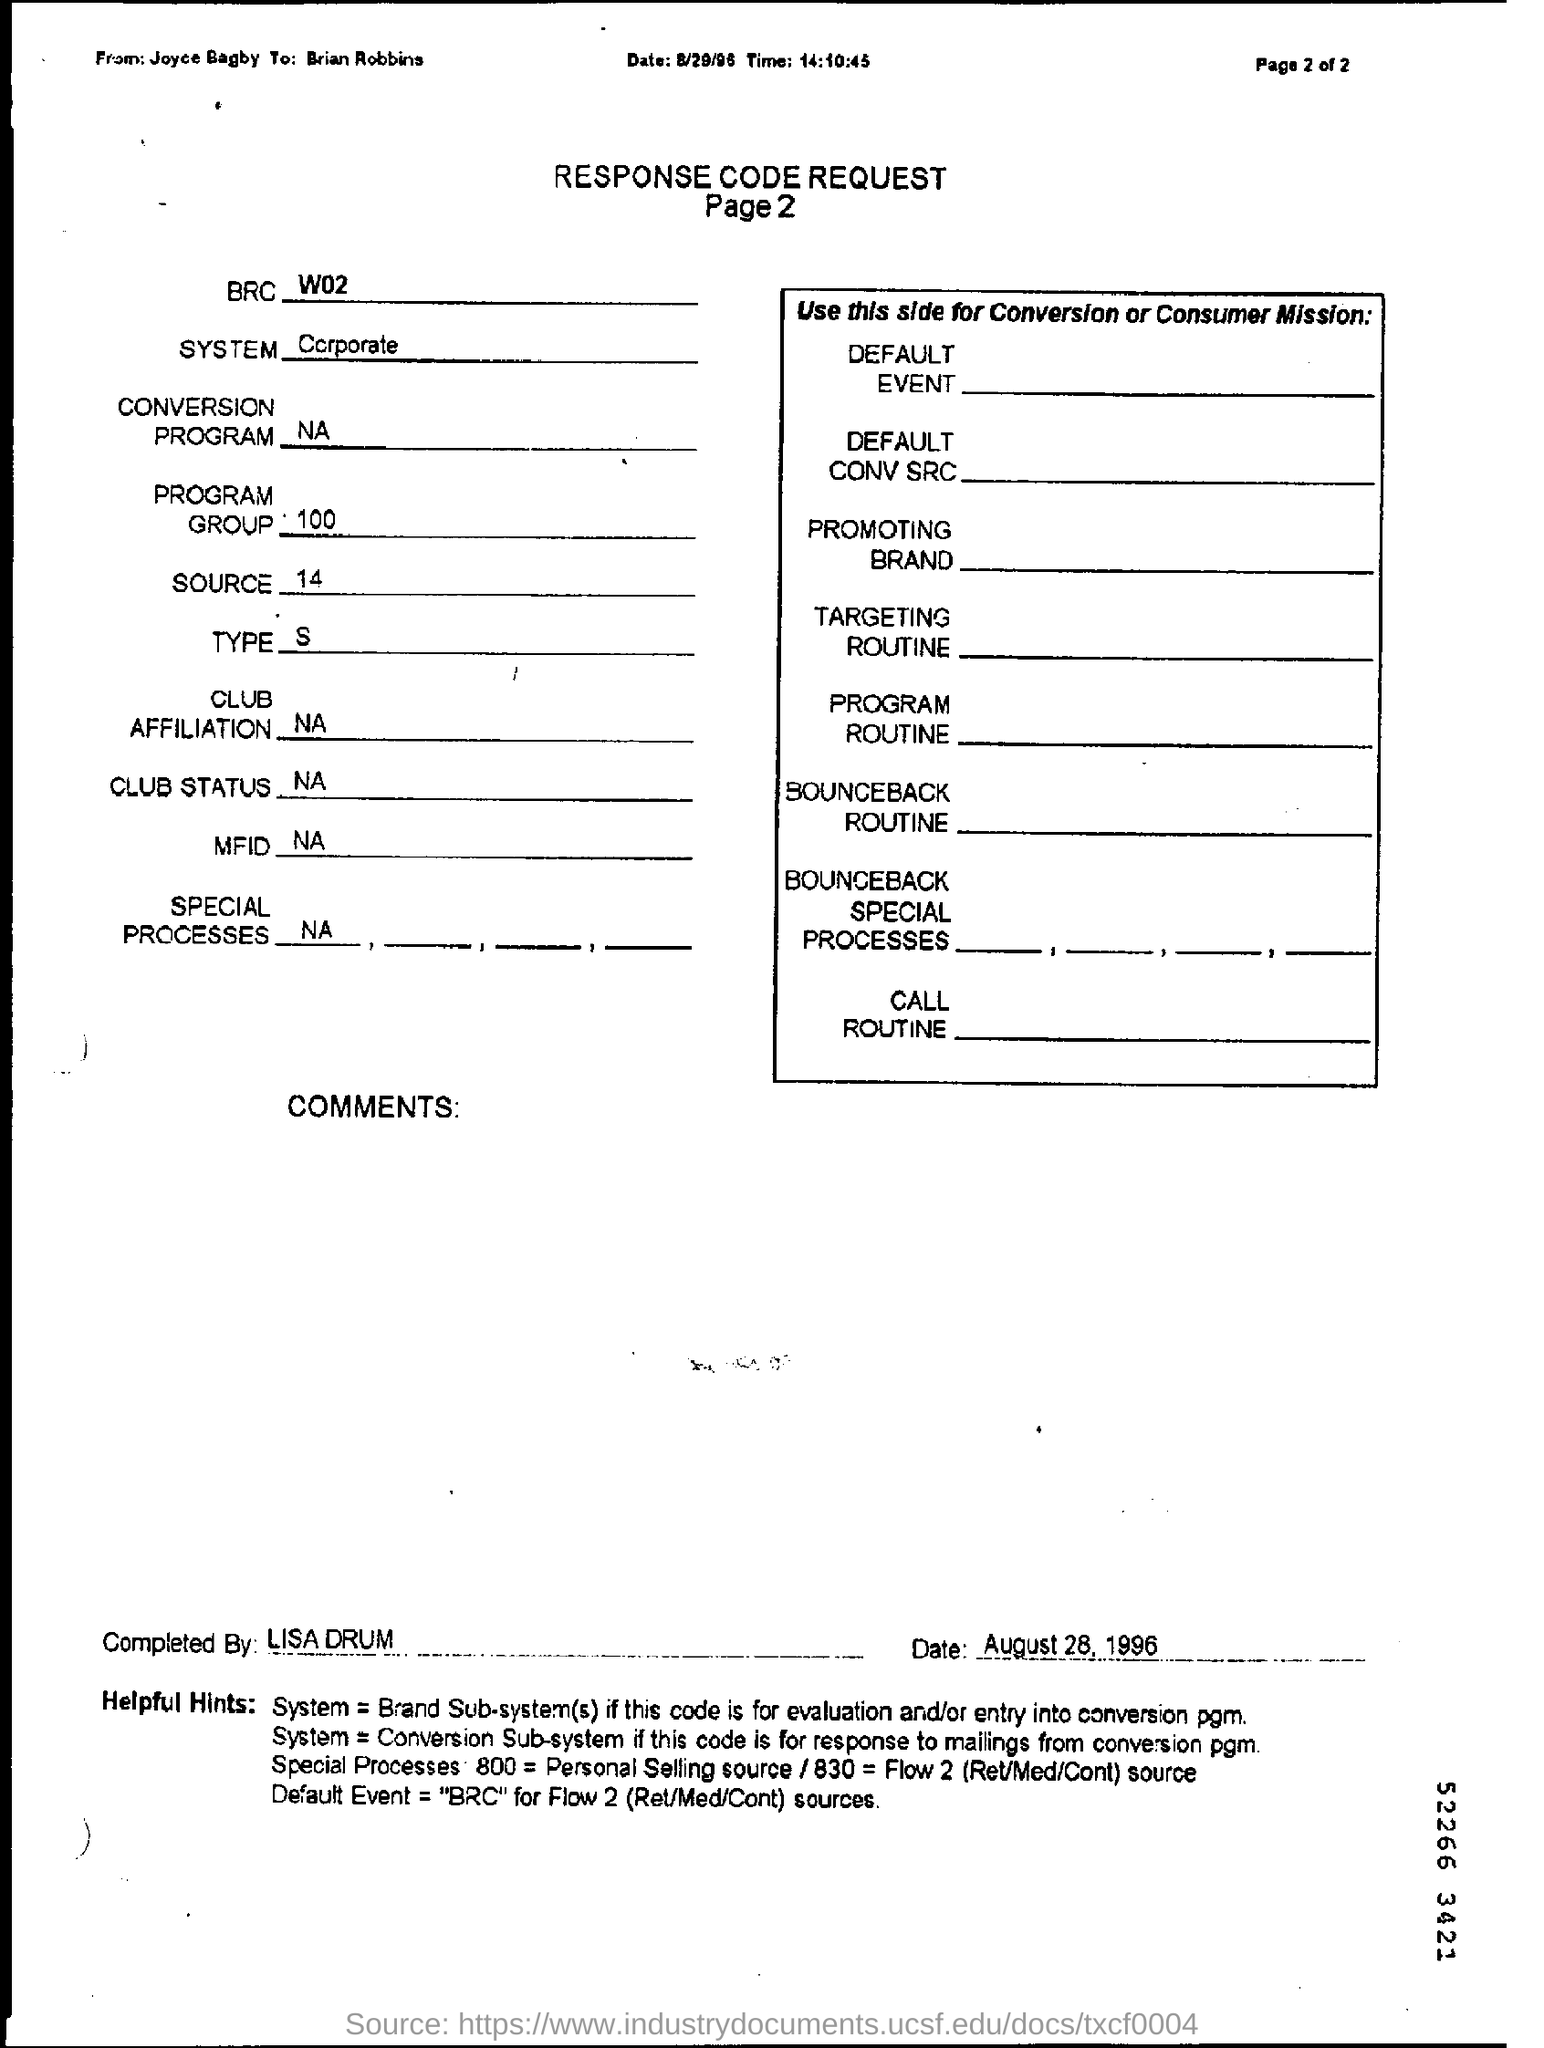Could you explain the 'Helpful Hints' section at the bottom of this document? The 'Helpful Hints' section provides guidance on how to interpret the response codes. It connects different system types with evaluation processes and conversion programs, indicating which system or event to refer to for various response code designations. For example, it suggests that if the code is for evaluation or entry into a conversion program ('conv pgm'), you should refer to the 'Brand Sub-system'. 